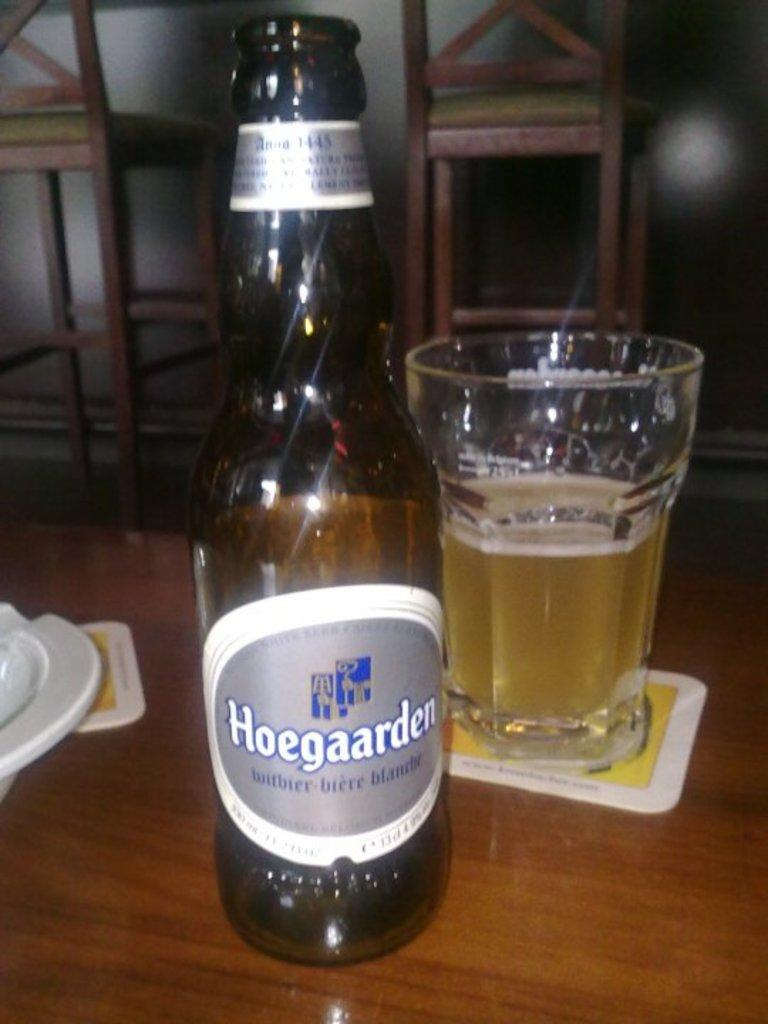<image>
Create a compact narrative representing the image presented. A glass bottle of Hoegaarden next to a half-full glass of alcohol. 